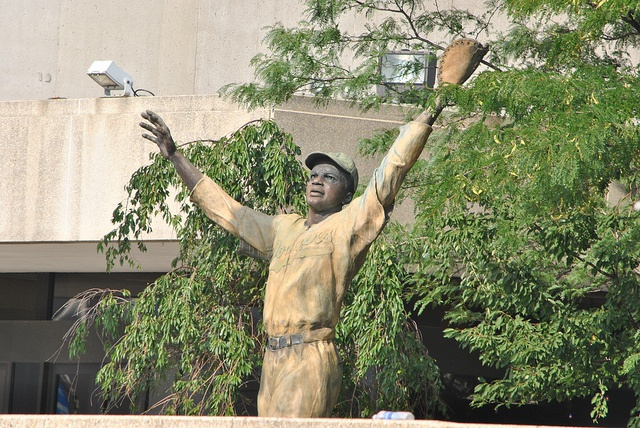Describe the objects in this image and their specific colors. I can see people in lightgray, tan, and darkgray tones, baseball glove in lightgray, tan, black, and darkgreen tones, and bottle in lightgray, lavender, darkgray, brown, and lightblue tones in this image. 